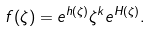<formula> <loc_0><loc_0><loc_500><loc_500>f ( \zeta ) = e ^ { h ( \zeta ) } \zeta ^ { k } e ^ { H ( \zeta ) } .</formula> 